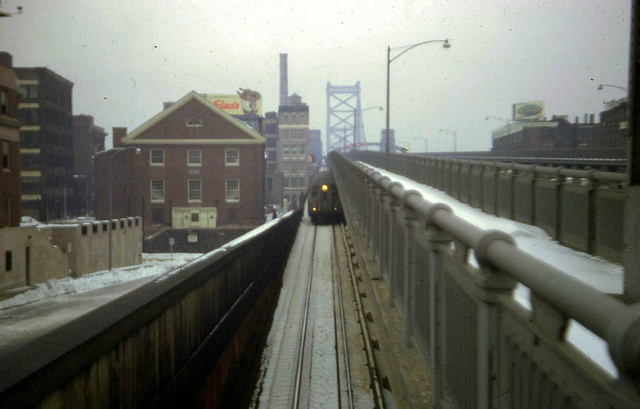Describe the objects in this image and their specific colors. I can see a train in gray and black tones in this image. 